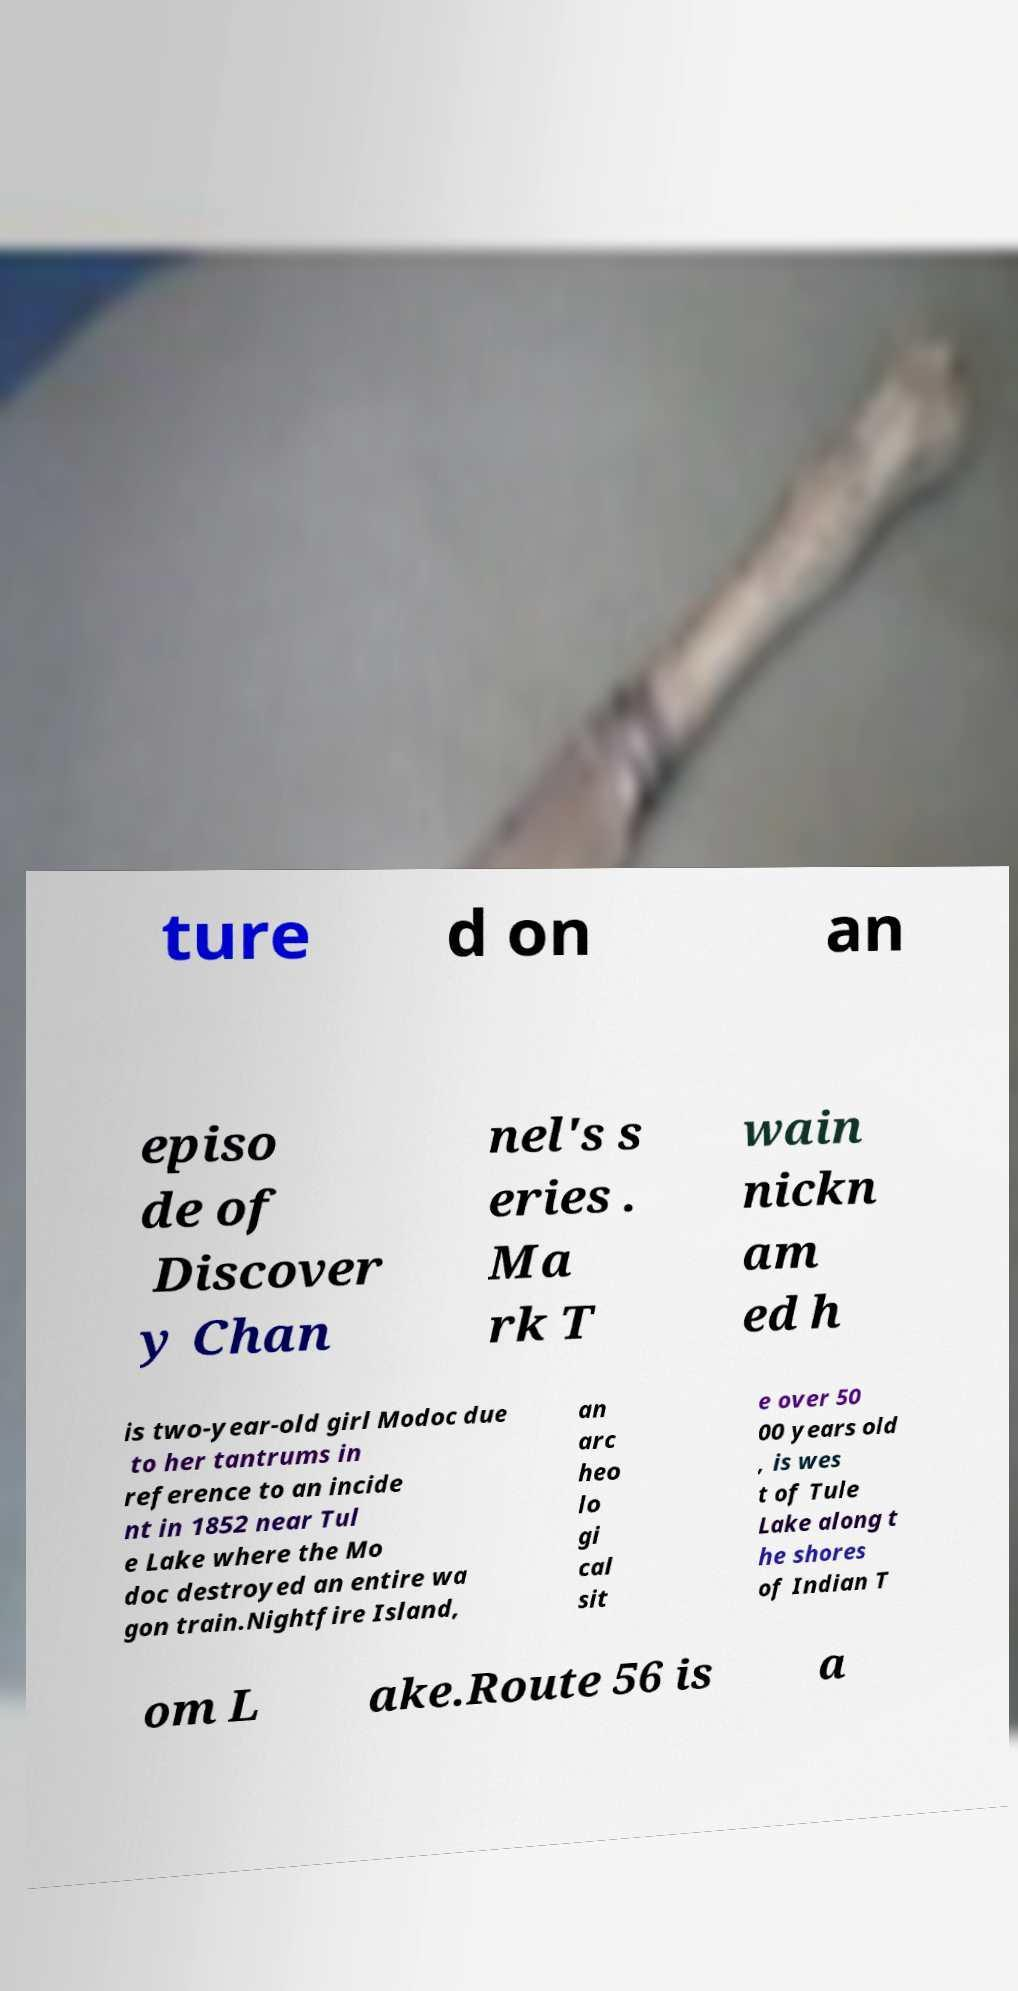Please identify and transcribe the text found in this image. ture d on an episo de of Discover y Chan nel's s eries . Ma rk T wain nickn am ed h is two-year-old girl Modoc due to her tantrums in reference to an incide nt in 1852 near Tul e Lake where the Mo doc destroyed an entire wa gon train.Nightfire Island, an arc heo lo gi cal sit e over 50 00 years old , is wes t of Tule Lake along t he shores of Indian T om L ake.Route 56 is a 